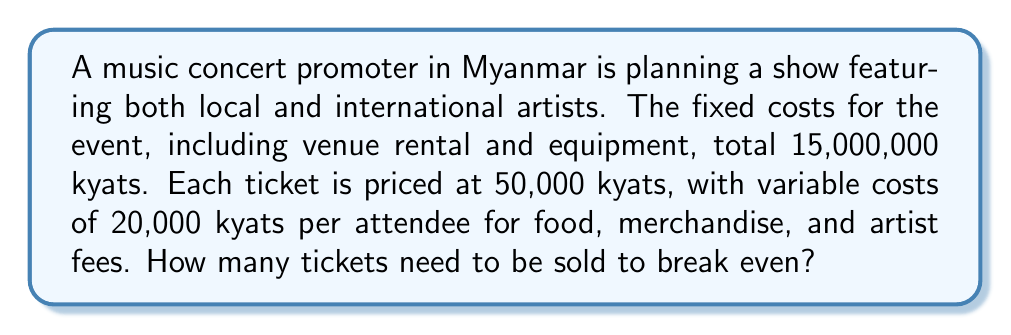What is the answer to this math problem? Let's approach this step-by-step using a linear equation:

1) Define variables:
   $x$ = number of tickets sold
   $R$ = Revenue
   $C$ = Total Costs

2) Express Revenue as a function of tickets sold:
   $R = 50000x$

3) Express Total Costs as a function of tickets sold:
   $C = 15000000 + 20000x$

4) At the break-even point, Revenue equals Total Costs:
   $R = C$
   $50000x = 15000000 + 20000x$

5) Solve the equation:
   $50000x - 20000x = 15000000$
   $30000x = 15000000$

6) Divide both sides by 30000:
   $x = \frac{15000000}{30000} = 500$

Therefore, 500 tickets need to be sold to break even.
Answer: 500 tickets 